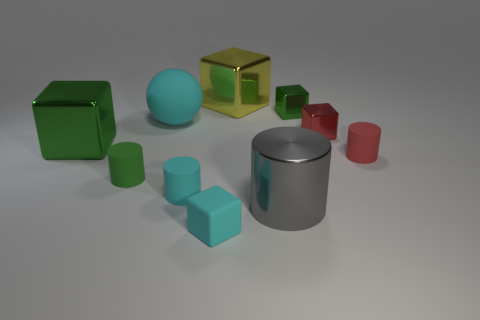What shape is the green metal thing right of the large shiny cube that is left of the large metal object behind the big green shiny thing?
Offer a very short reply. Cube. There is a red thing that is the same shape as the gray metal object; what is its size?
Give a very brief answer. Small. What size is the metallic thing that is in front of the red shiny block and to the right of the big cyan rubber ball?
Your answer should be compact. Large. There is a big matte object that is the same color as the rubber block; what shape is it?
Provide a short and direct response. Sphere. What color is the metallic cylinder?
Your response must be concise. Gray. There is a green thing to the right of the large cyan thing; what is its size?
Give a very brief answer. Small. How many green things are to the left of the large shiny cube that is behind the small green cube that is behind the big sphere?
Ensure brevity in your answer.  2. What is the color of the big cube right of the green object that is in front of the big green metal thing?
Provide a short and direct response. Yellow. Is there another yellow block that has the same size as the yellow shiny block?
Offer a terse response. No. There is a cube behind the green cube that is behind the matte thing behind the red cylinder; what is its material?
Give a very brief answer. Metal. 